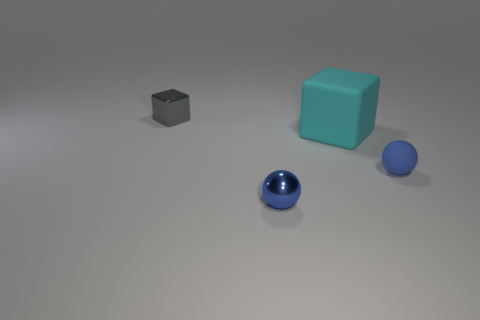Subtract all gray blocks. How many blocks are left? 1 Add 3 small yellow matte cubes. How many objects exist? 7 Subtract 0 purple cubes. How many objects are left? 4 Subtract all gray blocks. Subtract all cyan balls. How many blocks are left? 1 Subtract all brown balls. How many yellow cubes are left? 0 Subtract all large red cubes. Subtract all gray metal blocks. How many objects are left? 3 Add 1 balls. How many balls are left? 3 Add 2 small brown rubber spheres. How many small brown rubber spheres exist? 2 